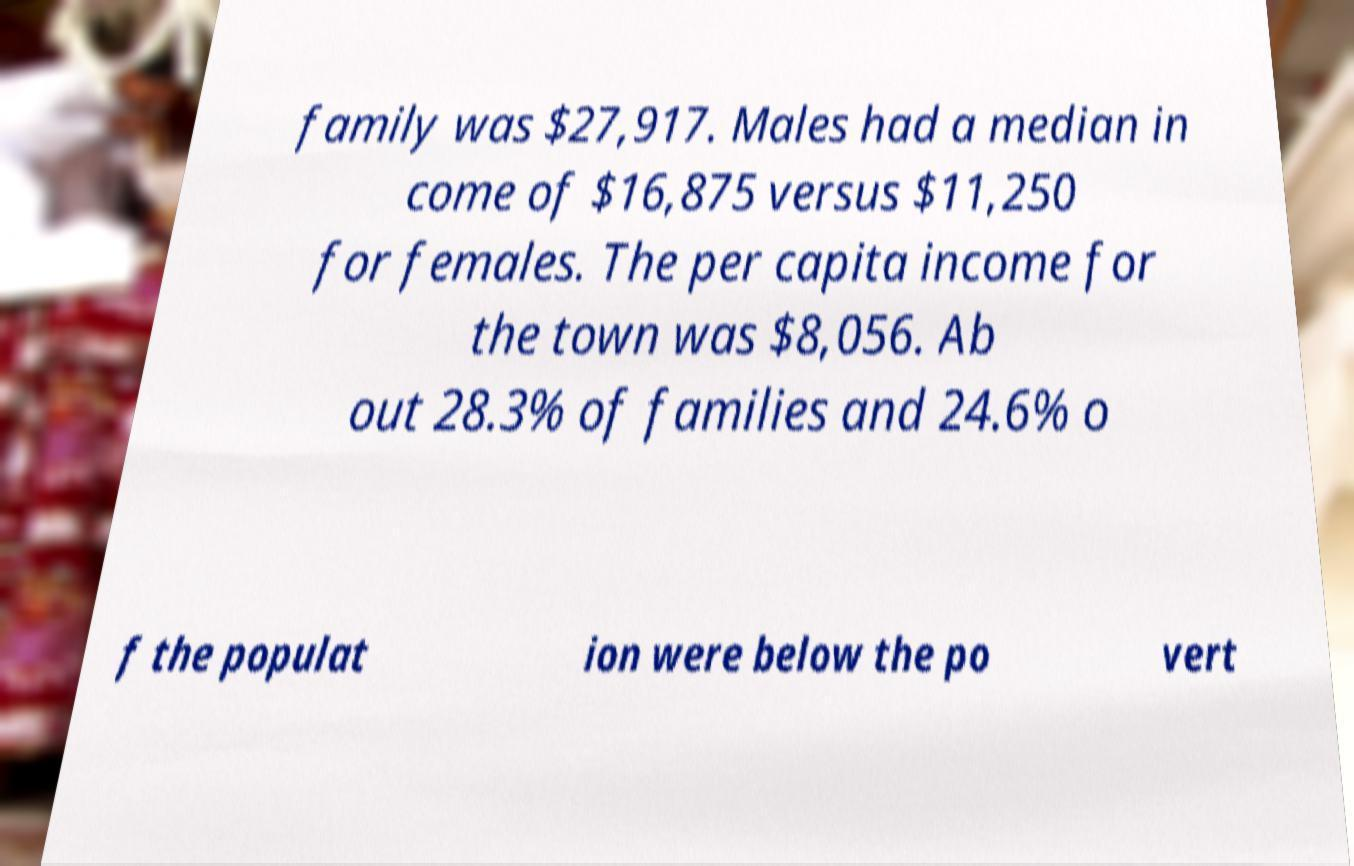There's text embedded in this image that I need extracted. Can you transcribe it verbatim? family was $27,917. Males had a median in come of $16,875 versus $11,250 for females. The per capita income for the town was $8,056. Ab out 28.3% of families and 24.6% o f the populat ion were below the po vert 